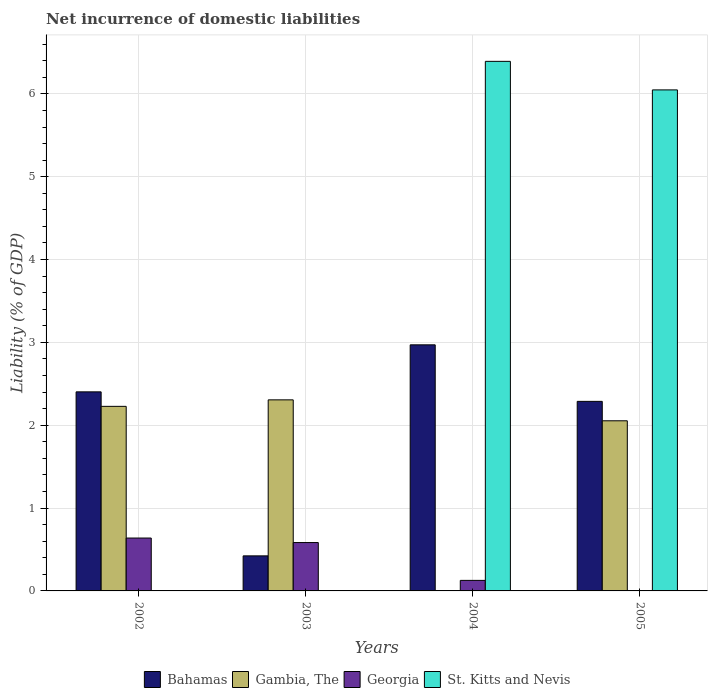How many different coloured bars are there?
Ensure brevity in your answer.  4. How many groups of bars are there?
Make the answer very short. 4. In how many cases, is the number of bars for a given year not equal to the number of legend labels?
Provide a short and direct response. 4. What is the net incurrence of domestic liabilities in St. Kitts and Nevis in 2005?
Make the answer very short. 6.05. Across all years, what is the maximum net incurrence of domestic liabilities in St. Kitts and Nevis?
Provide a succinct answer. 6.39. In which year was the net incurrence of domestic liabilities in Gambia, The maximum?
Offer a very short reply. 2003. What is the total net incurrence of domestic liabilities in Bahamas in the graph?
Offer a terse response. 8.08. What is the difference between the net incurrence of domestic liabilities in Bahamas in 2002 and that in 2005?
Keep it short and to the point. 0.11. What is the difference between the net incurrence of domestic liabilities in Gambia, The in 2005 and the net incurrence of domestic liabilities in Bahamas in 2003?
Your answer should be very brief. 1.63. What is the average net incurrence of domestic liabilities in Bahamas per year?
Give a very brief answer. 2.02. In the year 2002, what is the difference between the net incurrence of domestic liabilities in Gambia, The and net incurrence of domestic liabilities in Bahamas?
Your response must be concise. -0.18. In how many years, is the net incurrence of domestic liabilities in Georgia greater than 2 %?
Offer a terse response. 0. What is the ratio of the net incurrence of domestic liabilities in Bahamas in 2003 to that in 2004?
Provide a succinct answer. 0.14. Is the net incurrence of domestic liabilities in Gambia, The in 2003 less than that in 2005?
Keep it short and to the point. No. What is the difference between the highest and the second highest net incurrence of domestic liabilities in Georgia?
Your answer should be compact. 0.05. What is the difference between the highest and the lowest net incurrence of domestic liabilities in Bahamas?
Make the answer very short. 2.55. In how many years, is the net incurrence of domestic liabilities in Bahamas greater than the average net incurrence of domestic liabilities in Bahamas taken over all years?
Offer a very short reply. 3. How many bars are there?
Your answer should be very brief. 12. Are all the bars in the graph horizontal?
Provide a short and direct response. No. What is the difference between two consecutive major ticks on the Y-axis?
Provide a succinct answer. 1. Are the values on the major ticks of Y-axis written in scientific E-notation?
Your answer should be compact. No. Does the graph contain grids?
Provide a succinct answer. Yes. How many legend labels are there?
Your response must be concise. 4. How are the legend labels stacked?
Your response must be concise. Horizontal. What is the title of the graph?
Your answer should be compact. Net incurrence of domestic liabilities. What is the label or title of the Y-axis?
Make the answer very short. Liability (% of GDP). What is the Liability (% of GDP) in Bahamas in 2002?
Your answer should be very brief. 2.4. What is the Liability (% of GDP) in Gambia, The in 2002?
Your answer should be compact. 2.23. What is the Liability (% of GDP) in Georgia in 2002?
Offer a very short reply. 0.64. What is the Liability (% of GDP) of St. Kitts and Nevis in 2002?
Ensure brevity in your answer.  0. What is the Liability (% of GDP) in Bahamas in 2003?
Keep it short and to the point. 0.42. What is the Liability (% of GDP) of Gambia, The in 2003?
Ensure brevity in your answer.  2.31. What is the Liability (% of GDP) of Georgia in 2003?
Make the answer very short. 0.58. What is the Liability (% of GDP) in St. Kitts and Nevis in 2003?
Your answer should be very brief. 0. What is the Liability (% of GDP) in Bahamas in 2004?
Offer a terse response. 2.97. What is the Liability (% of GDP) of Gambia, The in 2004?
Keep it short and to the point. 0. What is the Liability (% of GDP) of Georgia in 2004?
Your answer should be compact. 0.13. What is the Liability (% of GDP) in St. Kitts and Nevis in 2004?
Offer a very short reply. 6.39. What is the Liability (% of GDP) of Bahamas in 2005?
Your answer should be compact. 2.29. What is the Liability (% of GDP) of Gambia, The in 2005?
Provide a short and direct response. 2.05. What is the Liability (% of GDP) of St. Kitts and Nevis in 2005?
Your response must be concise. 6.05. Across all years, what is the maximum Liability (% of GDP) in Bahamas?
Give a very brief answer. 2.97. Across all years, what is the maximum Liability (% of GDP) of Gambia, The?
Your response must be concise. 2.31. Across all years, what is the maximum Liability (% of GDP) of Georgia?
Ensure brevity in your answer.  0.64. Across all years, what is the maximum Liability (% of GDP) in St. Kitts and Nevis?
Keep it short and to the point. 6.39. Across all years, what is the minimum Liability (% of GDP) of Bahamas?
Your response must be concise. 0.42. Across all years, what is the minimum Liability (% of GDP) of Gambia, The?
Make the answer very short. 0. What is the total Liability (% of GDP) of Bahamas in the graph?
Your response must be concise. 8.08. What is the total Liability (% of GDP) in Gambia, The in the graph?
Offer a very short reply. 6.59. What is the total Liability (% of GDP) in Georgia in the graph?
Your answer should be compact. 1.35. What is the total Liability (% of GDP) in St. Kitts and Nevis in the graph?
Offer a terse response. 12.44. What is the difference between the Liability (% of GDP) in Bahamas in 2002 and that in 2003?
Ensure brevity in your answer.  1.98. What is the difference between the Liability (% of GDP) in Gambia, The in 2002 and that in 2003?
Provide a short and direct response. -0.08. What is the difference between the Liability (% of GDP) of Georgia in 2002 and that in 2003?
Your answer should be compact. 0.05. What is the difference between the Liability (% of GDP) of Bahamas in 2002 and that in 2004?
Ensure brevity in your answer.  -0.57. What is the difference between the Liability (% of GDP) of Georgia in 2002 and that in 2004?
Give a very brief answer. 0.51. What is the difference between the Liability (% of GDP) of Bahamas in 2002 and that in 2005?
Offer a very short reply. 0.11. What is the difference between the Liability (% of GDP) in Gambia, The in 2002 and that in 2005?
Provide a short and direct response. 0.17. What is the difference between the Liability (% of GDP) of Bahamas in 2003 and that in 2004?
Your answer should be compact. -2.55. What is the difference between the Liability (% of GDP) in Georgia in 2003 and that in 2004?
Offer a terse response. 0.46. What is the difference between the Liability (% of GDP) of Bahamas in 2003 and that in 2005?
Make the answer very short. -1.87. What is the difference between the Liability (% of GDP) of Gambia, The in 2003 and that in 2005?
Keep it short and to the point. 0.25. What is the difference between the Liability (% of GDP) in Bahamas in 2004 and that in 2005?
Offer a very short reply. 0.68. What is the difference between the Liability (% of GDP) of St. Kitts and Nevis in 2004 and that in 2005?
Provide a short and direct response. 0.34. What is the difference between the Liability (% of GDP) of Bahamas in 2002 and the Liability (% of GDP) of Gambia, The in 2003?
Offer a terse response. 0.1. What is the difference between the Liability (% of GDP) of Bahamas in 2002 and the Liability (% of GDP) of Georgia in 2003?
Offer a very short reply. 1.82. What is the difference between the Liability (% of GDP) in Gambia, The in 2002 and the Liability (% of GDP) in Georgia in 2003?
Provide a succinct answer. 1.64. What is the difference between the Liability (% of GDP) of Bahamas in 2002 and the Liability (% of GDP) of Georgia in 2004?
Keep it short and to the point. 2.28. What is the difference between the Liability (% of GDP) in Bahamas in 2002 and the Liability (% of GDP) in St. Kitts and Nevis in 2004?
Provide a succinct answer. -3.99. What is the difference between the Liability (% of GDP) in Gambia, The in 2002 and the Liability (% of GDP) in Georgia in 2004?
Provide a succinct answer. 2.1. What is the difference between the Liability (% of GDP) of Gambia, The in 2002 and the Liability (% of GDP) of St. Kitts and Nevis in 2004?
Make the answer very short. -4.16. What is the difference between the Liability (% of GDP) in Georgia in 2002 and the Liability (% of GDP) in St. Kitts and Nevis in 2004?
Your answer should be very brief. -5.75. What is the difference between the Liability (% of GDP) of Bahamas in 2002 and the Liability (% of GDP) of Gambia, The in 2005?
Give a very brief answer. 0.35. What is the difference between the Liability (% of GDP) of Bahamas in 2002 and the Liability (% of GDP) of St. Kitts and Nevis in 2005?
Your answer should be compact. -3.65. What is the difference between the Liability (% of GDP) of Gambia, The in 2002 and the Liability (% of GDP) of St. Kitts and Nevis in 2005?
Give a very brief answer. -3.82. What is the difference between the Liability (% of GDP) of Georgia in 2002 and the Liability (% of GDP) of St. Kitts and Nevis in 2005?
Give a very brief answer. -5.41. What is the difference between the Liability (% of GDP) of Bahamas in 2003 and the Liability (% of GDP) of Georgia in 2004?
Keep it short and to the point. 0.3. What is the difference between the Liability (% of GDP) of Bahamas in 2003 and the Liability (% of GDP) of St. Kitts and Nevis in 2004?
Provide a succinct answer. -5.97. What is the difference between the Liability (% of GDP) in Gambia, The in 2003 and the Liability (% of GDP) in Georgia in 2004?
Give a very brief answer. 2.18. What is the difference between the Liability (% of GDP) in Gambia, The in 2003 and the Liability (% of GDP) in St. Kitts and Nevis in 2004?
Keep it short and to the point. -4.09. What is the difference between the Liability (% of GDP) of Georgia in 2003 and the Liability (% of GDP) of St. Kitts and Nevis in 2004?
Offer a terse response. -5.81. What is the difference between the Liability (% of GDP) of Bahamas in 2003 and the Liability (% of GDP) of Gambia, The in 2005?
Ensure brevity in your answer.  -1.63. What is the difference between the Liability (% of GDP) of Bahamas in 2003 and the Liability (% of GDP) of St. Kitts and Nevis in 2005?
Offer a terse response. -5.63. What is the difference between the Liability (% of GDP) in Gambia, The in 2003 and the Liability (% of GDP) in St. Kitts and Nevis in 2005?
Ensure brevity in your answer.  -3.74. What is the difference between the Liability (% of GDP) in Georgia in 2003 and the Liability (% of GDP) in St. Kitts and Nevis in 2005?
Keep it short and to the point. -5.46. What is the difference between the Liability (% of GDP) in Bahamas in 2004 and the Liability (% of GDP) in Gambia, The in 2005?
Ensure brevity in your answer.  0.92. What is the difference between the Liability (% of GDP) of Bahamas in 2004 and the Liability (% of GDP) of St. Kitts and Nevis in 2005?
Your response must be concise. -3.08. What is the difference between the Liability (% of GDP) in Georgia in 2004 and the Liability (% of GDP) in St. Kitts and Nevis in 2005?
Give a very brief answer. -5.92. What is the average Liability (% of GDP) of Bahamas per year?
Your answer should be very brief. 2.02. What is the average Liability (% of GDP) of Gambia, The per year?
Your response must be concise. 1.65. What is the average Liability (% of GDP) of Georgia per year?
Provide a short and direct response. 0.34. What is the average Liability (% of GDP) of St. Kitts and Nevis per year?
Provide a short and direct response. 3.11. In the year 2002, what is the difference between the Liability (% of GDP) in Bahamas and Liability (% of GDP) in Gambia, The?
Offer a very short reply. 0.17. In the year 2002, what is the difference between the Liability (% of GDP) in Bahamas and Liability (% of GDP) in Georgia?
Offer a terse response. 1.76. In the year 2002, what is the difference between the Liability (% of GDP) in Gambia, The and Liability (% of GDP) in Georgia?
Offer a very short reply. 1.59. In the year 2003, what is the difference between the Liability (% of GDP) in Bahamas and Liability (% of GDP) in Gambia, The?
Keep it short and to the point. -1.88. In the year 2003, what is the difference between the Liability (% of GDP) in Bahamas and Liability (% of GDP) in Georgia?
Offer a terse response. -0.16. In the year 2003, what is the difference between the Liability (% of GDP) in Gambia, The and Liability (% of GDP) in Georgia?
Your answer should be compact. 1.72. In the year 2004, what is the difference between the Liability (% of GDP) of Bahamas and Liability (% of GDP) of Georgia?
Your answer should be very brief. 2.84. In the year 2004, what is the difference between the Liability (% of GDP) of Bahamas and Liability (% of GDP) of St. Kitts and Nevis?
Provide a succinct answer. -3.42. In the year 2004, what is the difference between the Liability (% of GDP) of Georgia and Liability (% of GDP) of St. Kitts and Nevis?
Offer a very short reply. -6.27. In the year 2005, what is the difference between the Liability (% of GDP) in Bahamas and Liability (% of GDP) in Gambia, The?
Offer a terse response. 0.23. In the year 2005, what is the difference between the Liability (% of GDP) in Bahamas and Liability (% of GDP) in St. Kitts and Nevis?
Offer a very short reply. -3.76. In the year 2005, what is the difference between the Liability (% of GDP) of Gambia, The and Liability (% of GDP) of St. Kitts and Nevis?
Ensure brevity in your answer.  -3.99. What is the ratio of the Liability (% of GDP) of Bahamas in 2002 to that in 2003?
Make the answer very short. 5.68. What is the ratio of the Liability (% of GDP) of Gambia, The in 2002 to that in 2003?
Ensure brevity in your answer.  0.97. What is the ratio of the Liability (% of GDP) of Georgia in 2002 to that in 2003?
Provide a short and direct response. 1.09. What is the ratio of the Liability (% of GDP) of Bahamas in 2002 to that in 2004?
Give a very brief answer. 0.81. What is the ratio of the Liability (% of GDP) in Georgia in 2002 to that in 2004?
Provide a short and direct response. 5.02. What is the ratio of the Liability (% of GDP) in Bahamas in 2002 to that in 2005?
Your answer should be very brief. 1.05. What is the ratio of the Liability (% of GDP) of Gambia, The in 2002 to that in 2005?
Keep it short and to the point. 1.08. What is the ratio of the Liability (% of GDP) of Bahamas in 2003 to that in 2004?
Provide a short and direct response. 0.14. What is the ratio of the Liability (% of GDP) of Georgia in 2003 to that in 2004?
Provide a short and direct response. 4.59. What is the ratio of the Liability (% of GDP) in Bahamas in 2003 to that in 2005?
Provide a short and direct response. 0.18. What is the ratio of the Liability (% of GDP) in Gambia, The in 2003 to that in 2005?
Keep it short and to the point. 1.12. What is the ratio of the Liability (% of GDP) in Bahamas in 2004 to that in 2005?
Make the answer very short. 1.3. What is the ratio of the Liability (% of GDP) of St. Kitts and Nevis in 2004 to that in 2005?
Your answer should be very brief. 1.06. What is the difference between the highest and the second highest Liability (% of GDP) of Bahamas?
Your answer should be compact. 0.57. What is the difference between the highest and the second highest Liability (% of GDP) in Gambia, The?
Your answer should be compact. 0.08. What is the difference between the highest and the second highest Liability (% of GDP) of Georgia?
Offer a terse response. 0.05. What is the difference between the highest and the lowest Liability (% of GDP) in Bahamas?
Offer a terse response. 2.55. What is the difference between the highest and the lowest Liability (% of GDP) in Gambia, The?
Make the answer very short. 2.31. What is the difference between the highest and the lowest Liability (% of GDP) of Georgia?
Offer a terse response. 0.64. What is the difference between the highest and the lowest Liability (% of GDP) of St. Kitts and Nevis?
Provide a short and direct response. 6.39. 